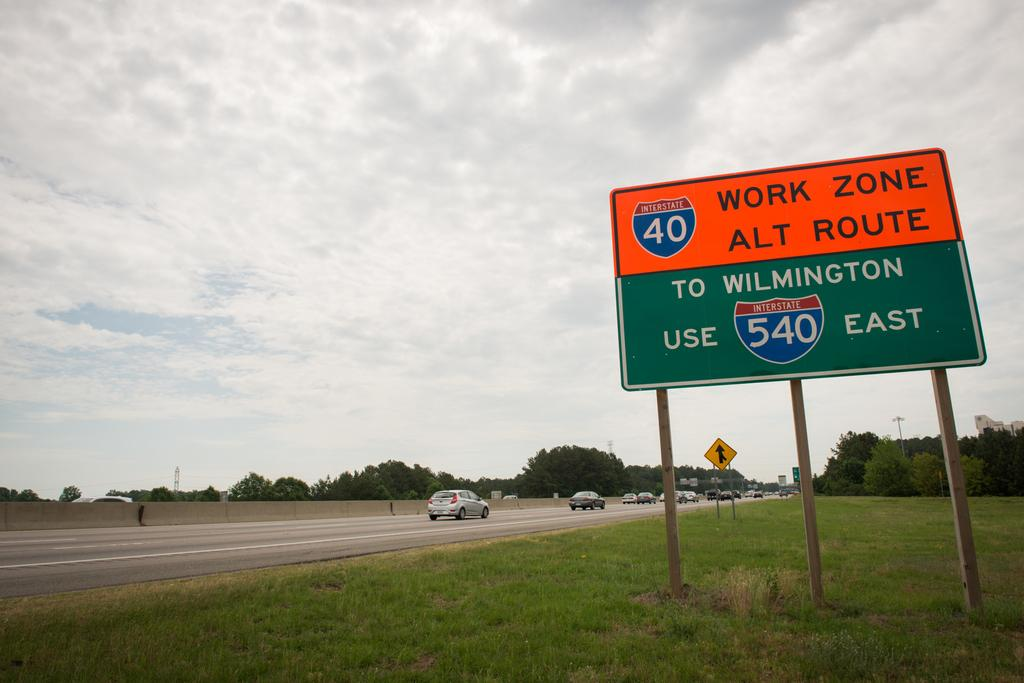<image>
Offer a succinct explanation of the picture presented. The road that has construction is Interstate 40 